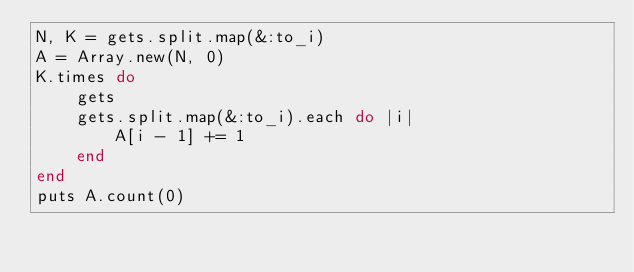<code> <loc_0><loc_0><loc_500><loc_500><_Ruby_>N, K = gets.split.map(&:to_i)
A = Array.new(N, 0)
K.times do 
    gets
    gets.split.map(&:to_i).each do |i|
        A[i - 1] += 1
    end
end
puts A.count(0)
</code> 